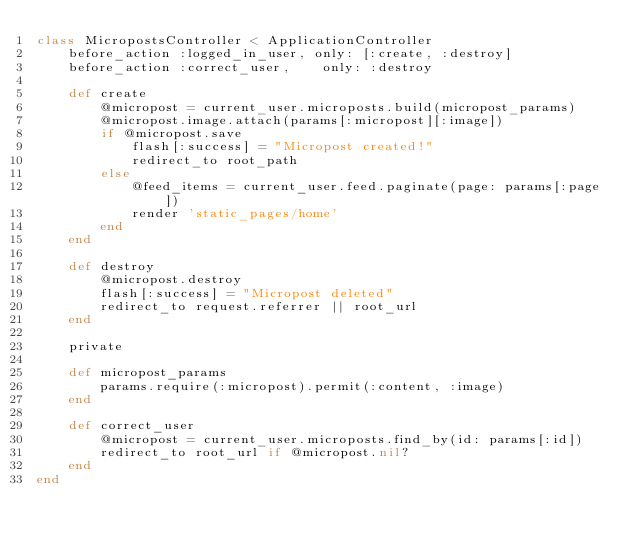Convert code to text. <code><loc_0><loc_0><loc_500><loc_500><_Ruby_>class MicropostsController < ApplicationController
    before_action :logged_in_user, only: [:create, :destroy]
    before_action :correct_user,    only: :destroy

    def create
        @micropost = current_user.microposts.build(micropost_params)
        @micropost.image.attach(params[:micropost][:image])
        if @micropost.save
            flash[:success] = "Micropost created!"
            redirect_to root_path
        else
            @feed_items = current_user.feed.paginate(page: params[:page])
            render 'static_pages/home'
        end
    end

    def destroy
        @micropost.destroy
        flash[:success] = "Micropost deleted"
        redirect_to request.referrer || root_url
    end

    private

    def micropost_params
        params.require(:micropost).permit(:content, :image)
    end

    def correct_user
        @micropost = current_user.microposts.find_by(id: params[:id])
        redirect_to root_url if @micropost.nil?
    end
end
</code> 